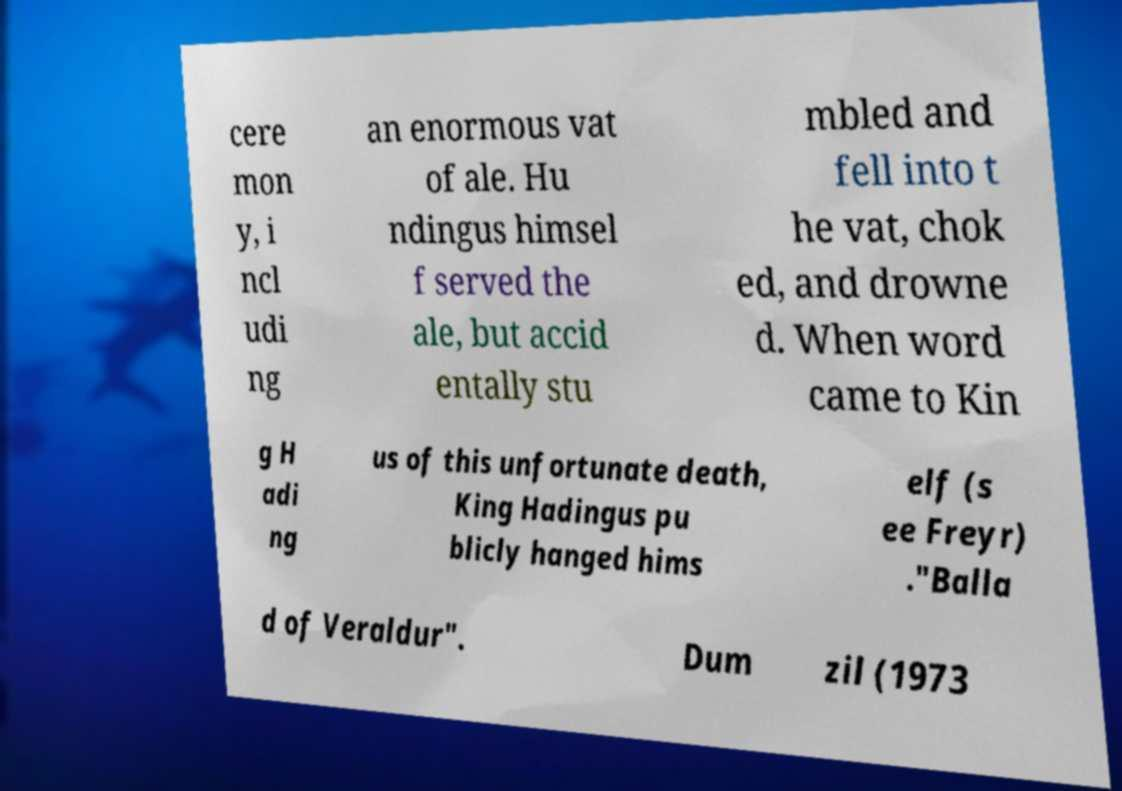Please read and relay the text visible in this image. What does it say? cere mon y, i ncl udi ng an enormous vat of ale. Hu ndingus himsel f served the ale, but accid entally stu mbled and fell into t he vat, chok ed, and drowne d. When word came to Kin g H adi ng us of this unfortunate death, King Hadingus pu blicly hanged hims elf (s ee Freyr) ."Balla d of Veraldur". Dum zil (1973 